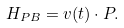<formula> <loc_0><loc_0><loc_500><loc_500>H _ { P B } = { v } ( t ) \cdot { P } .</formula> 